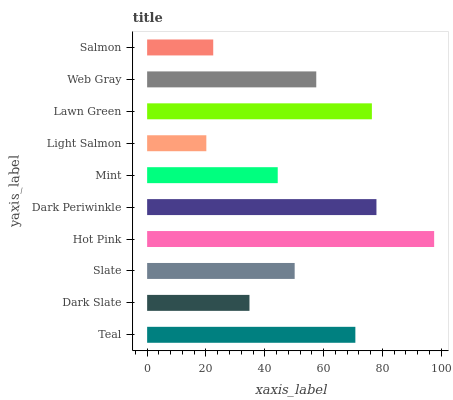Is Light Salmon the minimum?
Answer yes or no. Yes. Is Hot Pink the maximum?
Answer yes or no. Yes. Is Dark Slate the minimum?
Answer yes or no. No. Is Dark Slate the maximum?
Answer yes or no. No. Is Teal greater than Dark Slate?
Answer yes or no. Yes. Is Dark Slate less than Teal?
Answer yes or no. Yes. Is Dark Slate greater than Teal?
Answer yes or no. No. Is Teal less than Dark Slate?
Answer yes or no. No. Is Web Gray the high median?
Answer yes or no. Yes. Is Slate the low median?
Answer yes or no. Yes. Is Lawn Green the high median?
Answer yes or no. No. Is Hot Pink the low median?
Answer yes or no. No. 